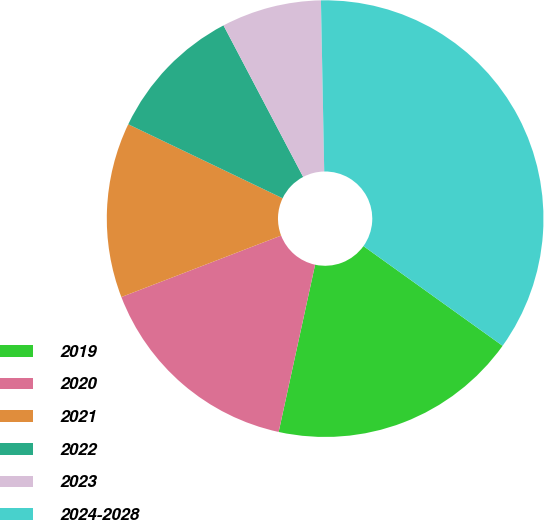Convert chart. <chart><loc_0><loc_0><loc_500><loc_500><pie_chart><fcel>2019<fcel>2020<fcel>2021<fcel>2022<fcel>2023<fcel>2024-2028<nl><fcel>18.52%<fcel>15.74%<fcel>12.96%<fcel>10.18%<fcel>7.4%<fcel>35.2%<nl></chart> 